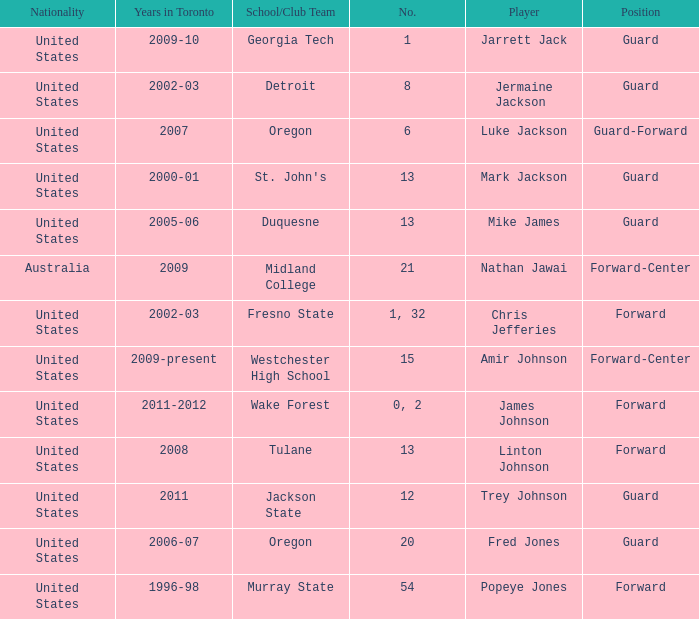What school/club team is Amir Johnson on? Westchester High School. 